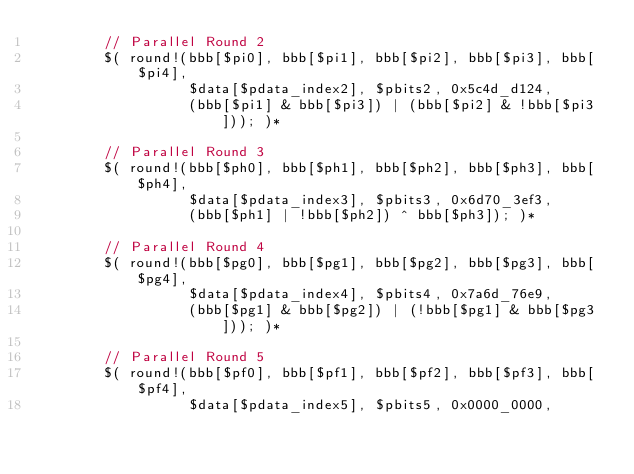Convert code to text. <code><loc_0><loc_0><loc_500><loc_500><_Rust_>        // Parallel Round 2
        $( round!(bbb[$pi0], bbb[$pi1], bbb[$pi2], bbb[$pi3], bbb[$pi4],
                  $data[$pdata_index2], $pbits2, 0x5c4d_d124,
                  (bbb[$pi1] & bbb[$pi3]) | (bbb[$pi2] & !bbb[$pi3])); )*

        // Parallel Round 3
        $( round!(bbb[$ph0], bbb[$ph1], bbb[$ph2], bbb[$ph3], bbb[$ph4],
                  $data[$pdata_index3], $pbits3, 0x6d70_3ef3,
                  (bbb[$ph1] | !bbb[$ph2]) ^ bbb[$ph3]); )*

        // Parallel Round 4
        $( round!(bbb[$pg0], bbb[$pg1], bbb[$pg2], bbb[$pg3], bbb[$pg4],
                  $data[$pdata_index4], $pbits4, 0x7a6d_76e9,
                  (bbb[$pg1] & bbb[$pg2]) | (!bbb[$pg1] & bbb[$pg3])); )*

        // Parallel Round 5
        $( round!(bbb[$pf0], bbb[$pf1], bbb[$pf2], bbb[$pf3], bbb[$pf4],
                  $data[$pdata_index5], $pbits5, 0x0000_0000,</code> 